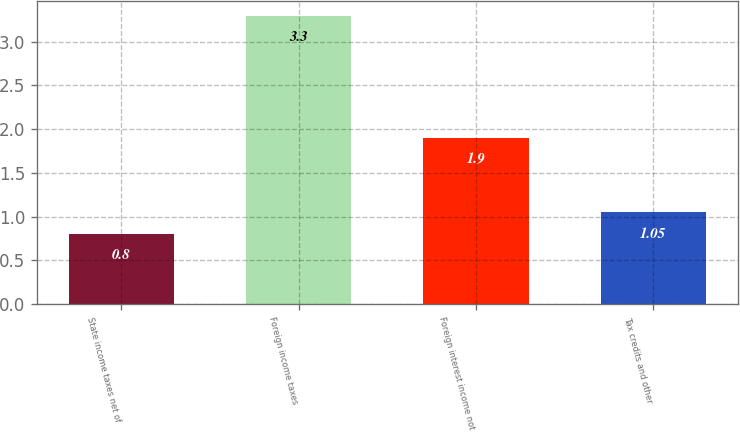Convert chart to OTSL. <chart><loc_0><loc_0><loc_500><loc_500><bar_chart><fcel>State income taxes net of<fcel>Foreign income taxes<fcel>Foreign interest income not<fcel>Tax credits and other<nl><fcel>0.8<fcel>3.3<fcel>1.9<fcel>1.05<nl></chart> 